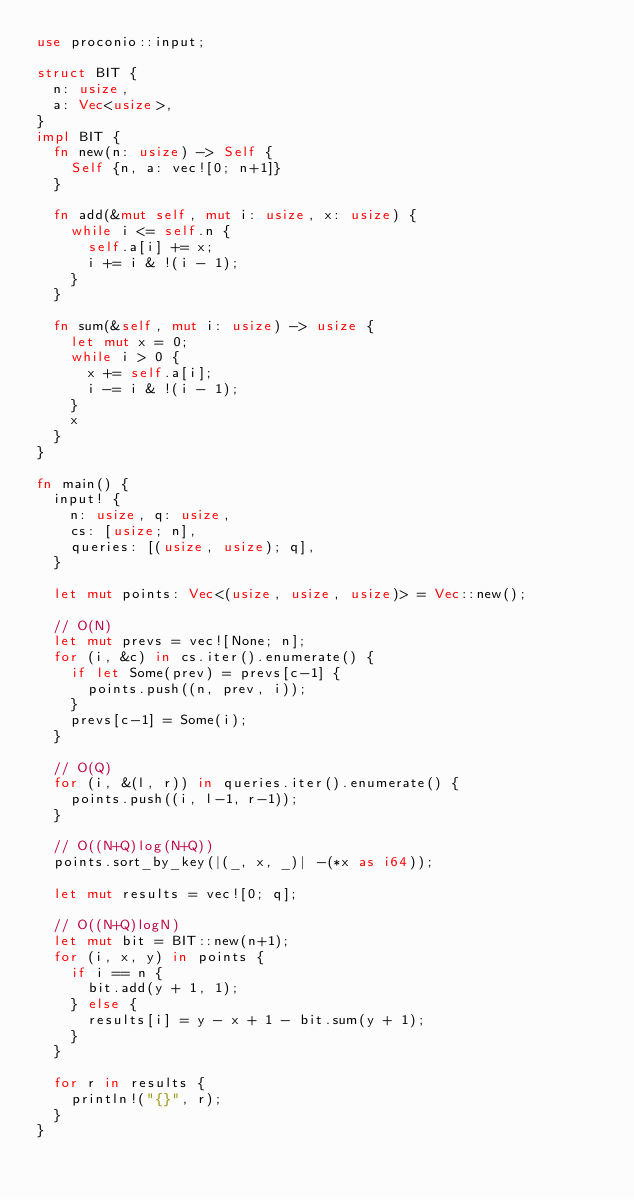Convert code to text. <code><loc_0><loc_0><loc_500><loc_500><_Rust_>use proconio::input;

struct BIT {
  n: usize,
  a: Vec<usize>,
}
impl BIT {
  fn new(n: usize) -> Self {
    Self {n, a: vec![0; n+1]}
  }

  fn add(&mut self, mut i: usize, x: usize) {
    while i <= self.n {
      self.a[i] += x;
      i += i & !(i - 1);
    }
  }

  fn sum(&self, mut i: usize) -> usize {
    let mut x = 0;
    while i > 0 {
      x += self.a[i];
      i -= i & !(i - 1);
    }
    x
  }
}

fn main() {
  input! {
    n: usize, q: usize,
    cs: [usize; n],
    queries: [(usize, usize); q],
  }

  let mut points: Vec<(usize, usize, usize)> = Vec::new();

  // O(N)
  let mut prevs = vec![None; n];
  for (i, &c) in cs.iter().enumerate() {
    if let Some(prev) = prevs[c-1] {
      points.push((n, prev, i));
    }
    prevs[c-1] = Some(i);
  }

  // O(Q)
  for (i, &(l, r)) in queries.iter().enumerate() {
    points.push((i, l-1, r-1));
  }

  // O((N+Q)log(N+Q))
  points.sort_by_key(|(_, x, _)| -(*x as i64));

  let mut results = vec![0; q];

  // O((N+Q)logN)
  let mut bit = BIT::new(n+1);
  for (i, x, y) in points {
    if i == n {
      bit.add(y + 1, 1);
    } else {
      results[i] = y - x + 1 - bit.sum(y + 1);
    }
  }

  for r in results {
    println!("{}", r);
  }
}
</code> 